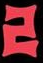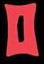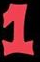What text is displayed in these images sequentially, separated by a semicolon? 2; 0; 1 